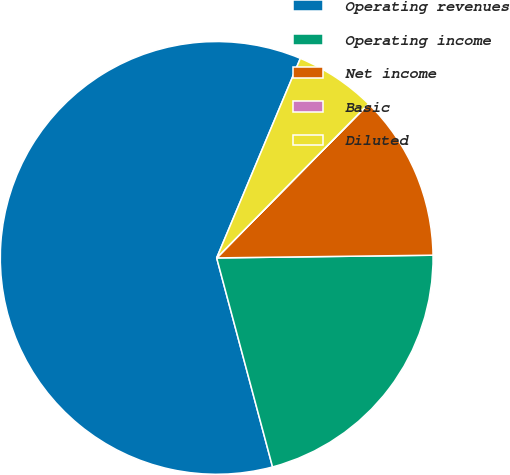Convert chart. <chart><loc_0><loc_0><loc_500><loc_500><pie_chart><fcel>Operating revenues<fcel>Operating income<fcel>Net income<fcel>Basic<fcel>Diluted<nl><fcel>60.47%<fcel>21.04%<fcel>12.41%<fcel>0.01%<fcel>6.06%<nl></chart> 